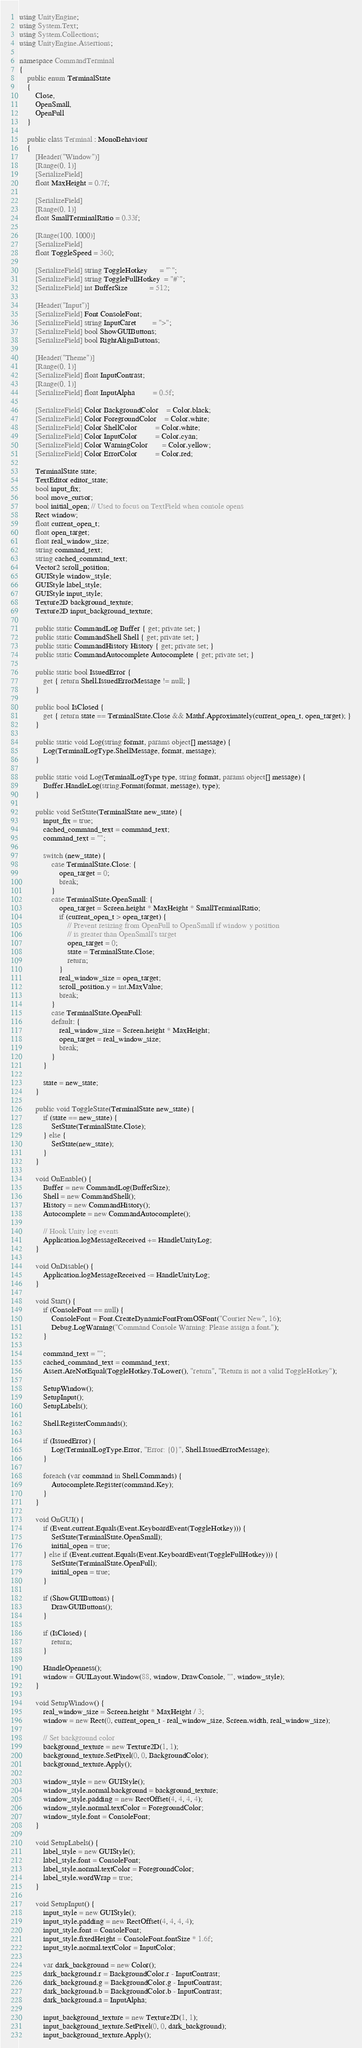Convert code to text. <code><loc_0><loc_0><loc_500><loc_500><_C#_>using UnityEngine;
using System.Text;
using System.Collections;
using UnityEngine.Assertions;

namespace CommandTerminal
{
    public enum TerminalState
    {
        Close,
        OpenSmall,
        OpenFull
    }

    public class Terminal : MonoBehaviour
    {
        [Header("Window")]
        [Range(0, 1)]
        [SerializeField]
        float MaxHeight = 0.7f;

        [SerializeField]
        [Range(0, 1)]
        float SmallTerminalRatio = 0.33f;

        [Range(100, 1000)]
        [SerializeField]
        float ToggleSpeed = 360;

        [SerializeField] string ToggleHotkey      = "`";
        [SerializeField] string ToggleFullHotkey  = "#`";
        [SerializeField] int BufferSize           = 512;

        [Header("Input")]
        [SerializeField] Font ConsoleFont;
        [SerializeField] string InputCaret        = ">";
        [SerializeField] bool ShowGUIButtons;
        [SerializeField] bool RightAlignButtons;

        [Header("Theme")]
        [Range(0, 1)]
        [SerializeField] float InputContrast;
        [Range(0, 1)]
        [SerializeField] float InputAlpha         = 0.5f;

        [SerializeField] Color BackgroundColor    = Color.black;
        [SerializeField] Color ForegroundColor    = Color.white;
        [SerializeField] Color ShellColor         = Color.white;
        [SerializeField] Color InputColor         = Color.cyan;
        [SerializeField] Color WarningColor       = Color.yellow;
        [SerializeField] Color ErrorColor         = Color.red;

        TerminalState state;
        TextEditor editor_state;
        bool input_fix;
        bool move_cursor;
        bool initial_open; // Used to focus on TextField when console opens
        Rect window;
        float current_open_t;
        float open_target;
        float real_window_size;
        string command_text;
        string cached_command_text;
        Vector2 scroll_position;
        GUIStyle window_style;
        GUIStyle label_style;
        GUIStyle input_style;
        Texture2D background_texture;
        Texture2D input_background_texture;

        public static CommandLog Buffer { get; private set; }
        public static CommandShell Shell { get; private set; }
        public static CommandHistory History { get; private set; }
        public static CommandAutocomplete Autocomplete { get; private set; }

        public static bool IssuedError {
            get { return Shell.IssuedErrorMessage != null; }
        }

        public bool IsClosed {
            get { return state == TerminalState.Close && Mathf.Approximately(current_open_t, open_target); }
        }

        public static void Log(string format, params object[] message) {
            Log(TerminalLogType.ShellMessage, format, message);
        }

        public static void Log(TerminalLogType type, string format, params object[] message) {
            Buffer.HandleLog(string.Format(format, message), type);
        }

        public void SetState(TerminalState new_state) {
            input_fix = true;
            cached_command_text = command_text;
            command_text = "";

            switch (new_state) {
                case TerminalState.Close: {
                    open_target = 0;
                    break;
                }
                case TerminalState.OpenSmall: {
                    open_target = Screen.height * MaxHeight * SmallTerminalRatio;
                    if (current_open_t > open_target) {
                        // Prevent resizing from OpenFull to OpenSmall if window y position
                        // is greater than OpenSmall's target
                        open_target = 0;
                        state = TerminalState.Close;
                        return;
                    }
                    real_window_size = open_target;
                    scroll_position.y = int.MaxValue;
                    break;
                }
                case TerminalState.OpenFull:
                default: {
                    real_window_size = Screen.height * MaxHeight;
                    open_target = real_window_size;
                    break;
                }
            }

            state = new_state;
        }

        public void ToggleState(TerminalState new_state) {
            if (state == new_state) {
                SetState(TerminalState.Close);
            } else {
                SetState(new_state);
            }
        }

        void OnEnable() {
            Buffer = new CommandLog(BufferSize);
            Shell = new CommandShell();
            History = new CommandHistory();
            Autocomplete = new CommandAutocomplete();

            // Hook Unity log events
            Application.logMessageReceived += HandleUnityLog;
        }

        void OnDisable() {
            Application.logMessageReceived -= HandleUnityLog;
        }

        void Start() {
            if (ConsoleFont == null) {
                ConsoleFont = Font.CreateDynamicFontFromOSFont("Courier New", 16);
                Debug.LogWarning("Command Console Warning: Please assign a font.");
            }

            command_text = "";
            cached_command_text = command_text;
            Assert.AreNotEqual(ToggleHotkey.ToLower(), "return", "Return is not a valid ToggleHotkey");

            SetupWindow();
            SetupInput();
            SetupLabels();

            Shell.RegisterCommands();

            if (IssuedError) {
                Log(TerminalLogType.Error, "Error: {0}", Shell.IssuedErrorMessage);
            }

            foreach (var command in Shell.Commands) {
                Autocomplete.Register(command.Key);
            }
        }

        void OnGUI() {
            if (Event.current.Equals(Event.KeyboardEvent(ToggleHotkey))) {
                SetState(TerminalState.OpenSmall);
                initial_open = true;
            } else if (Event.current.Equals(Event.KeyboardEvent(ToggleFullHotkey))) {
                SetState(TerminalState.OpenFull);
                initial_open = true;
            }

            if (ShowGUIButtons) {
                DrawGUIButtons();
            }

            if (IsClosed) {
                return;
            }

            HandleOpenness();
            window = GUILayout.Window(88, window, DrawConsole, "", window_style);
        }

        void SetupWindow() {
            real_window_size = Screen.height * MaxHeight / 3;
            window = new Rect(0, current_open_t - real_window_size, Screen.width, real_window_size);

            // Set background color
            background_texture = new Texture2D(1, 1);
            background_texture.SetPixel(0, 0, BackgroundColor);
            background_texture.Apply();

            window_style = new GUIStyle();
            window_style.normal.background = background_texture;
            window_style.padding = new RectOffset(4, 4, 4, 4);
            window_style.normal.textColor = ForegroundColor;
            window_style.font = ConsoleFont;
        }

        void SetupLabels() {
            label_style = new GUIStyle();
            label_style.font = ConsoleFont;
            label_style.normal.textColor = ForegroundColor;
            label_style.wordWrap = true;
        }

        void SetupInput() {
            input_style = new GUIStyle();
            input_style.padding = new RectOffset(4, 4, 4, 4);
            input_style.font = ConsoleFont;
            input_style.fixedHeight = ConsoleFont.fontSize * 1.6f;
            input_style.normal.textColor = InputColor;

            var dark_background = new Color();
            dark_background.r = BackgroundColor.r - InputContrast;
            dark_background.g = BackgroundColor.g - InputContrast;
            dark_background.b = BackgroundColor.b - InputContrast;
            dark_background.a = InputAlpha;

            input_background_texture = new Texture2D(1, 1);
            input_background_texture.SetPixel(0, 0, dark_background);
            input_background_texture.Apply();</code> 